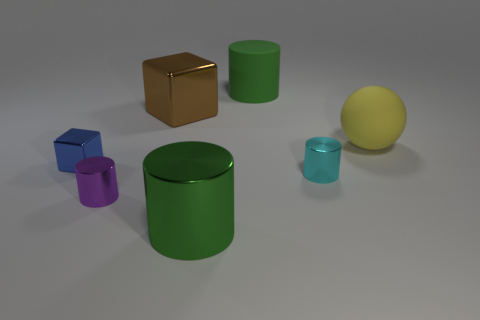The large matte object that is the same color as the large shiny cylinder is what shape?
Your answer should be compact. Cylinder. There is a cylinder that is on the left side of the big block; how big is it?
Provide a succinct answer. Small. What number of large green cylinders are both behind the tiny blue shiny block and in front of the large yellow object?
Make the answer very short. 0. The big cylinder in front of the green cylinder behind the tiny metallic block is made of what material?
Your answer should be very brief. Metal. What is the material of the other object that is the same shape as the small blue object?
Ensure brevity in your answer.  Metal. Is there a shiny block?
Give a very brief answer. Yes. What is the shape of the blue object that is the same material as the brown cube?
Give a very brief answer. Cube. What is the material of the large green object on the right side of the big green shiny cylinder?
Your answer should be very brief. Rubber. Do the large cylinder in front of the matte cylinder and the large matte cylinder have the same color?
Your answer should be compact. Yes. What size is the green thing to the left of the big green object that is behind the small purple thing?
Offer a terse response. Large. 